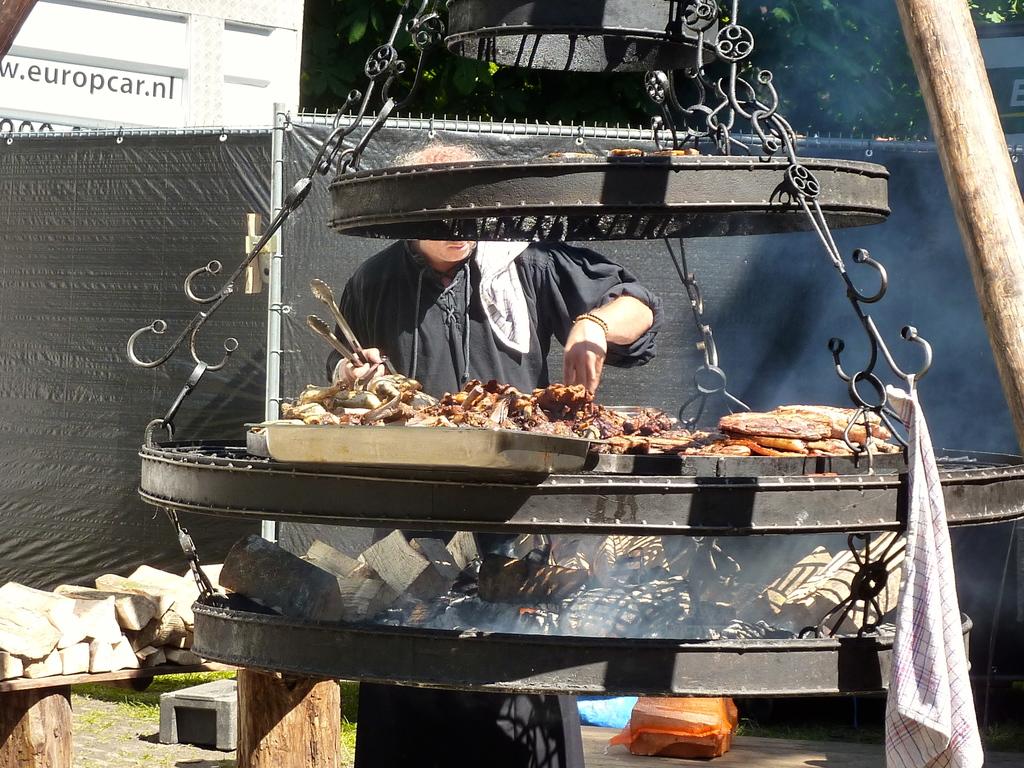What website is in the top left corner?
Offer a very short reply. Europcar.nl. 